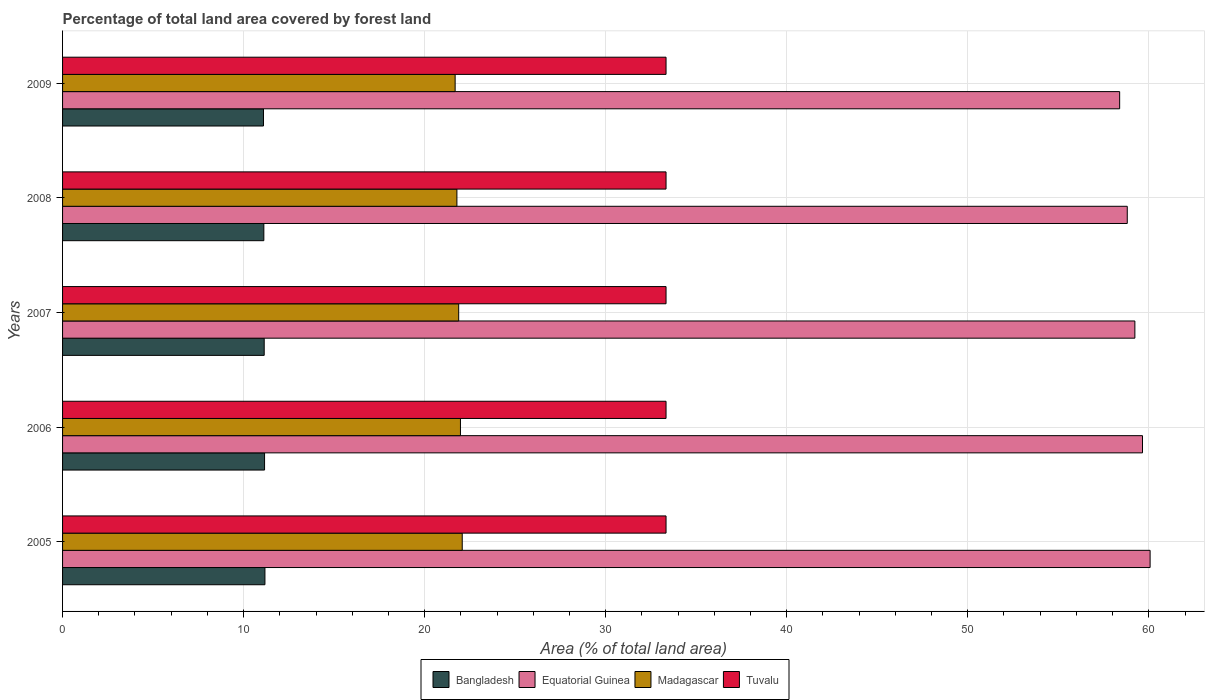Are the number of bars per tick equal to the number of legend labels?
Your answer should be very brief. Yes. Are the number of bars on each tick of the Y-axis equal?
Your response must be concise. Yes. How many bars are there on the 3rd tick from the top?
Offer a very short reply. 4. In how many cases, is the number of bars for a given year not equal to the number of legend labels?
Provide a succinct answer. 0. What is the percentage of forest land in Equatorial Guinea in 2009?
Your answer should be compact. 58.39. Across all years, what is the maximum percentage of forest land in Madagascar?
Ensure brevity in your answer.  22.08. Across all years, what is the minimum percentage of forest land in Bangladesh?
Provide a short and direct response. 11.1. In which year was the percentage of forest land in Tuvalu minimum?
Offer a terse response. 2005. What is the total percentage of forest land in Bangladesh in the graph?
Ensure brevity in your answer.  55.69. What is the difference between the percentage of forest land in Madagascar in 2006 and that in 2007?
Keep it short and to the point. 0.1. What is the difference between the percentage of forest land in Madagascar in 2008 and the percentage of forest land in Equatorial Guinea in 2007?
Make the answer very short. -37.45. What is the average percentage of forest land in Bangladesh per year?
Provide a succinct answer. 11.14. In the year 2009, what is the difference between the percentage of forest land in Equatorial Guinea and percentage of forest land in Madagascar?
Your answer should be compact. 36.7. In how many years, is the percentage of forest land in Madagascar greater than 4 %?
Keep it short and to the point. 5. What is the ratio of the percentage of forest land in Equatorial Guinea in 2005 to that in 2008?
Your response must be concise. 1.02. What is the difference between the highest and the second highest percentage of forest land in Bangladesh?
Keep it short and to the point. 0.02. What is the difference between the highest and the lowest percentage of forest land in Madagascar?
Provide a succinct answer. 0.39. Is it the case that in every year, the sum of the percentage of forest land in Bangladesh and percentage of forest land in Tuvalu is greater than the sum of percentage of forest land in Madagascar and percentage of forest land in Equatorial Guinea?
Provide a succinct answer. Yes. What does the 1st bar from the top in 2009 represents?
Your answer should be compact. Tuvalu. What does the 4th bar from the bottom in 2009 represents?
Offer a terse response. Tuvalu. How many bars are there?
Your answer should be compact. 20. How many years are there in the graph?
Your response must be concise. 5. Does the graph contain any zero values?
Offer a very short reply. No. What is the title of the graph?
Your answer should be very brief. Percentage of total land area covered by forest land. What is the label or title of the X-axis?
Offer a very short reply. Area (% of total land area). What is the label or title of the Y-axis?
Offer a very short reply. Years. What is the Area (% of total land area) of Bangladesh in 2005?
Ensure brevity in your answer.  11.18. What is the Area (% of total land area) of Equatorial Guinea in 2005?
Your answer should be compact. 60.07. What is the Area (% of total land area) of Madagascar in 2005?
Provide a short and direct response. 22.08. What is the Area (% of total land area) in Tuvalu in 2005?
Offer a terse response. 33.33. What is the Area (% of total land area) of Bangladesh in 2006?
Offer a terse response. 11.16. What is the Area (% of total land area) in Equatorial Guinea in 2006?
Give a very brief answer. 59.65. What is the Area (% of total land area) in Madagascar in 2006?
Provide a succinct answer. 21.98. What is the Area (% of total land area) in Tuvalu in 2006?
Give a very brief answer. 33.33. What is the Area (% of total land area) of Bangladesh in 2007?
Give a very brief answer. 11.14. What is the Area (% of total land area) of Equatorial Guinea in 2007?
Your answer should be compact. 59.23. What is the Area (% of total land area) in Madagascar in 2007?
Your response must be concise. 21.88. What is the Area (% of total land area) in Tuvalu in 2007?
Keep it short and to the point. 33.33. What is the Area (% of total land area) of Bangladesh in 2008?
Make the answer very short. 11.12. What is the Area (% of total land area) of Equatorial Guinea in 2008?
Provide a short and direct response. 58.81. What is the Area (% of total land area) in Madagascar in 2008?
Give a very brief answer. 21.78. What is the Area (% of total land area) of Tuvalu in 2008?
Keep it short and to the point. 33.33. What is the Area (% of total land area) of Bangladesh in 2009?
Provide a succinct answer. 11.1. What is the Area (% of total land area) in Equatorial Guinea in 2009?
Ensure brevity in your answer.  58.39. What is the Area (% of total land area) of Madagascar in 2009?
Ensure brevity in your answer.  21.68. What is the Area (% of total land area) in Tuvalu in 2009?
Provide a succinct answer. 33.33. Across all years, what is the maximum Area (% of total land area) in Bangladesh?
Your answer should be compact. 11.18. Across all years, what is the maximum Area (% of total land area) of Equatorial Guinea?
Offer a terse response. 60.07. Across all years, what is the maximum Area (% of total land area) of Madagascar?
Make the answer very short. 22.08. Across all years, what is the maximum Area (% of total land area) of Tuvalu?
Your response must be concise. 33.33. Across all years, what is the minimum Area (% of total land area) of Bangladesh?
Provide a short and direct response. 11.1. Across all years, what is the minimum Area (% of total land area) of Equatorial Guinea?
Ensure brevity in your answer.  58.39. Across all years, what is the minimum Area (% of total land area) in Madagascar?
Ensure brevity in your answer.  21.68. Across all years, what is the minimum Area (% of total land area) in Tuvalu?
Offer a very short reply. 33.33. What is the total Area (% of total land area) of Bangladesh in the graph?
Offer a terse response. 55.69. What is the total Area (% of total land area) of Equatorial Guinea in the graph?
Offer a very short reply. 296.15. What is the total Area (% of total land area) of Madagascar in the graph?
Provide a succinct answer. 109.4. What is the total Area (% of total land area) in Tuvalu in the graph?
Offer a very short reply. 166.67. What is the difference between the Area (% of total land area) in Equatorial Guinea in 2005 and that in 2006?
Make the answer very short. 0.42. What is the difference between the Area (% of total land area) in Madagascar in 2005 and that in 2006?
Your answer should be compact. 0.1. What is the difference between the Area (% of total land area) in Bangladesh in 2005 and that in 2007?
Offer a very short reply. 0.04. What is the difference between the Area (% of total land area) of Equatorial Guinea in 2005 and that in 2007?
Ensure brevity in your answer.  0.84. What is the difference between the Area (% of total land area) of Madagascar in 2005 and that in 2007?
Provide a succinct answer. 0.2. What is the difference between the Area (% of total land area) in Bangladesh in 2005 and that in 2008?
Give a very brief answer. 0.06. What is the difference between the Area (% of total land area) in Equatorial Guinea in 2005 and that in 2008?
Your response must be concise. 1.26. What is the difference between the Area (% of total land area) of Madagascar in 2005 and that in 2008?
Make the answer very short. 0.29. What is the difference between the Area (% of total land area) in Bangladesh in 2005 and that in 2009?
Make the answer very short. 0.08. What is the difference between the Area (% of total land area) of Equatorial Guinea in 2005 and that in 2009?
Give a very brief answer. 1.68. What is the difference between the Area (% of total land area) in Madagascar in 2005 and that in 2009?
Provide a succinct answer. 0.39. What is the difference between the Area (% of total land area) of Tuvalu in 2005 and that in 2009?
Give a very brief answer. 0. What is the difference between the Area (% of total land area) of Equatorial Guinea in 2006 and that in 2007?
Give a very brief answer. 0.42. What is the difference between the Area (% of total land area) of Madagascar in 2006 and that in 2007?
Make the answer very short. 0.1. What is the difference between the Area (% of total land area) of Bangladesh in 2006 and that in 2008?
Your answer should be compact. 0.04. What is the difference between the Area (% of total land area) in Equatorial Guinea in 2006 and that in 2008?
Provide a succinct answer. 0.84. What is the difference between the Area (% of total land area) in Madagascar in 2006 and that in 2008?
Give a very brief answer. 0.2. What is the difference between the Area (% of total land area) of Tuvalu in 2006 and that in 2008?
Provide a succinct answer. 0. What is the difference between the Area (% of total land area) in Bangladesh in 2006 and that in 2009?
Offer a very short reply. 0.06. What is the difference between the Area (% of total land area) in Equatorial Guinea in 2006 and that in 2009?
Offer a terse response. 1.26. What is the difference between the Area (% of total land area) of Madagascar in 2006 and that in 2009?
Offer a very short reply. 0.29. What is the difference between the Area (% of total land area) of Tuvalu in 2006 and that in 2009?
Offer a terse response. 0. What is the difference between the Area (% of total land area) in Equatorial Guinea in 2007 and that in 2008?
Your answer should be compact. 0.42. What is the difference between the Area (% of total land area) in Madagascar in 2007 and that in 2008?
Your answer should be compact. 0.1. What is the difference between the Area (% of total land area) in Tuvalu in 2007 and that in 2008?
Your answer should be very brief. 0. What is the difference between the Area (% of total land area) in Bangladesh in 2007 and that in 2009?
Your response must be concise. 0.04. What is the difference between the Area (% of total land area) of Equatorial Guinea in 2007 and that in 2009?
Your answer should be very brief. 0.84. What is the difference between the Area (% of total land area) in Madagascar in 2007 and that in 2009?
Your answer should be very brief. 0.2. What is the difference between the Area (% of total land area) in Equatorial Guinea in 2008 and that in 2009?
Provide a short and direct response. 0.42. What is the difference between the Area (% of total land area) in Madagascar in 2008 and that in 2009?
Give a very brief answer. 0.1. What is the difference between the Area (% of total land area) in Bangladesh in 2005 and the Area (% of total land area) in Equatorial Guinea in 2006?
Offer a very short reply. -48.47. What is the difference between the Area (% of total land area) of Bangladesh in 2005 and the Area (% of total land area) of Madagascar in 2006?
Ensure brevity in your answer.  -10.8. What is the difference between the Area (% of total land area) of Bangladesh in 2005 and the Area (% of total land area) of Tuvalu in 2006?
Make the answer very short. -22.16. What is the difference between the Area (% of total land area) in Equatorial Guinea in 2005 and the Area (% of total land area) in Madagascar in 2006?
Offer a very short reply. 38.09. What is the difference between the Area (% of total land area) in Equatorial Guinea in 2005 and the Area (% of total land area) in Tuvalu in 2006?
Your response must be concise. 26.74. What is the difference between the Area (% of total land area) of Madagascar in 2005 and the Area (% of total land area) of Tuvalu in 2006?
Ensure brevity in your answer.  -11.26. What is the difference between the Area (% of total land area) in Bangladesh in 2005 and the Area (% of total land area) in Equatorial Guinea in 2007?
Offer a terse response. -48.05. What is the difference between the Area (% of total land area) of Bangladesh in 2005 and the Area (% of total land area) of Madagascar in 2007?
Your answer should be compact. -10.7. What is the difference between the Area (% of total land area) in Bangladesh in 2005 and the Area (% of total land area) in Tuvalu in 2007?
Your response must be concise. -22.16. What is the difference between the Area (% of total land area) of Equatorial Guinea in 2005 and the Area (% of total land area) of Madagascar in 2007?
Offer a terse response. 38.19. What is the difference between the Area (% of total land area) of Equatorial Guinea in 2005 and the Area (% of total land area) of Tuvalu in 2007?
Your answer should be very brief. 26.74. What is the difference between the Area (% of total land area) of Madagascar in 2005 and the Area (% of total land area) of Tuvalu in 2007?
Give a very brief answer. -11.26. What is the difference between the Area (% of total land area) of Bangladesh in 2005 and the Area (% of total land area) of Equatorial Guinea in 2008?
Your response must be concise. -47.63. What is the difference between the Area (% of total land area) in Bangladesh in 2005 and the Area (% of total land area) in Madagascar in 2008?
Provide a short and direct response. -10.6. What is the difference between the Area (% of total land area) of Bangladesh in 2005 and the Area (% of total land area) of Tuvalu in 2008?
Your answer should be very brief. -22.16. What is the difference between the Area (% of total land area) in Equatorial Guinea in 2005 and the Area (% of total land area) in Madagascar in 2008?
Offer a terse response. 38.29. What is the difference between the Area (% of total land area) in Equatorial Guinea in 2005 and the Area (% of total land area) in Tuvalu in 2008?
Offer a very short reply. 26.74. What is the difference between the Area (% of total land area) in Madagascar in 2005 and the Area (% of total land area) in Tuvalu in 2008?
Your response must be concise. -11.26. What is the difference between the Area (% of total land area) of Bangladesh in 2005 and the Area (% of total land area) of Equatorial Guinea in 2009?
Your response must be concise. -47.21. What is the difference between the Area (% of total land area) in Bangladesh in 2005 and the Area (% of total land area) in Madagascar in 2009?
Offer a terse response. -10.51. What is the difference between the Area (% of total land area) in Bangladesh in 2005 and the Area (% of total land area) in Tuvalu in 2009?
Your answer should be very brief. -22.16. What is the difference between the Area (% of total land area) in Equatorial Guinea in 2005 and the Area (% of total land area) in Madagascar in 2009?
Give a very brief answer. 38.39. What is the difference between the Area (% of total land area) in Equatorial Guinea in 2005 and the Area (% of total land area) in Tuvalu in 2009?
Provide a succinct answer. 26.74. What is the difference between the Area (% of total land area) of Madagascar in 2005 and the Area (% of total land area) of Tuvalu in 2009?
Ensure brevity in your answer.  -11.26. What is the difference between the Area (% of total land area) in Bangladesh in 2006 and the Area (% of total land area) in Equatorial Guinea in 2007?
Keep it short and to the point. -48.07. What is the difference between the Area (% of total land area) in Bangladesh in 2006 and the Area (% of total land area) in Madagascar in 2007?
Provide a short and direct response. -10.72. What is the difference between the Area (% of total land area) in Bangladesh in 2006 and the Area (% of total land area) in Tuvalu in 2007?
Your answer should be very brief. -22.18. What is the difference between the Area (% of total land area) of Equatorial Guinea in 2006 and the Area (% of total land area) of Madagascar in 2007?
Your answer should be very brief. 37.77. What is the difference between the Area (% of total land area) of Equatorial Guinea in 2006 and the Area (% of total land area) of Tuvalu in 2007?
Your response must be concise. 26.32. What is the difference between the Area (% of total land area) of Madagascar in 2006 and the Area (% of total land area) of Tuvalu in 2007?
Give a very brief answer. -11.36. What is the difference between the Area (% of total land area) in Bangladesh in 2006 and the Area (% of total land area) in Equatorial Guinea in 2008?
Ensure brevity in your answer.  -47.65. What is the difference between the Area (% of total land area) of Bangladesh in 2006 and the Area (% of total land area) of Madagascar in 2008?
Offer a very short reply. -10.62. What is the difference between the Area (% of total land area) in Bangladesh in 2006 and the Area (% of total land area) in Tuvalu in 2008?
Your response must be concise. -22.18. What is the difference between the Area (% of total land area) of Equatorial Guinea in 2006 and the Area (% of total land area) of Madagascar in 2008?
Provide a short and direct response. 37.87. What is the difference between the Area (% of total land area) in Equatorial Guinea in 2006 and the Area (% of total land area) in Tuvalu in 2008?
Offer a terse response. 26.32. What is the difference between the Area (% of total land area) of Madagascar in 2006 and the Area (% of total land area) of Tuvalu in 2008?
Ensure brevity in your answer.  -11.36. What is the difference between the Area (% of total land area) in Bangladesh in 2006 and the Area (% of total land area) in Equatorial Guinea in 2009?
Provide a short and direct response. -47.23. What is the difference between the Area (% of total land area) in Bangladesh in 2006 and the Area (% of total land area) in Madagascar in 2009?
Your response must be concise. -10.53. What is the difference between the Area (% of total land area) of Bangladesh in 2006 and the Area (% of total land area) of Tuvalu in 2009?
Give a very brief answer. -22.18. What is the difference between the Area (% of total land area) in Equatorial Guinea in 2006 and the Area (% of total land area) in Madagascar in 2009?
Ensure brevity in your answer.  37.97. What is the difference between the Area (% of total land area) in Equatorial Guinea in 2006 and the Area (% of total land area) in Tuvalu in 2009?
Give a very brief answer. 26.32. What is the difference between the Area (% of total land area) in Madagascar in 2006 and the Area (% of total land area) in Tuvalu in 2009?
Provide a short and direct response. -11.36. What is the difference between the Area (% of total land area) in Bangladesh in 2007 and the Area (% of total land area) in Equatorial Guinea in 2008?
Offer a very short reply. -47.67. What is the difference between the Area (% of total land area) of Bangladesh in 2007 and the Area (% of total land area) of Madagascar in 2008?
Your response must be concise. -10.64. What is the difference between the Area (% of total land area) in Bangladesh in 2007 and the Area (% of total land area) in Tuvalu in 2008?
Ensure brevity in your answer.  -22.2. What is the difference between the Area (% of total land area) of Equatorial Guinea in 2007 and the Area (% of total land area) of Madagascar in 2008?
Your answer should be compact. 37.45. What is the difference between the Area (% of total land area) in Equatorial Guinea in 2007 and the Area (% of total land area) in Tuvalu in 2008?
Provide a short and direct response. 25.9. What is the difference between the Area (% of total land area) in Madagascar in 2007 and the Area (% of total land area) in Tuvalu in 2008?
Provide a short and direct response. -11.45. What is the difference between the Area (% of total land area) of Bangladesh in 2007 and the Area (% of total land area) of Equatorial Guinea in 2009?
Your answer should be compact. -47.25. What is the difference between the Area (% of total land area) in Bangladesh in 2007 and the Area (% of total land area) in Madagascar in 2009?
Offer a terse response. -10.55. What is the difference between the Area (% of total land area) in Bangladesh in 2007 and the Area (% of total land area) in Tuvalu in 2009?
Make the answer very short. -22.2. What is the difference between the Area (% of total land area) of Equatorial Guinea in 2007 and the Area (% of total land area) of Madagascar in 2009?
Provide a short and direct response. 37.55. What is the difference between the Area (% of total land area) of Equatorial Guinea in 2007 and the Area (% of total land area) of Tuvalu in 2009?
Provide a succinct answer. 25.9. What is the difference between the Area (% of total land area) of Madagascar in 2007 and the Area (% of total land area) of Tuvalu in 2009?
Your response must be concise. -11.45. What is the difference between the Area (% of total land area) of Bangladesh in 2008 and the Area (% of total land area) of Equatorial Guinea in 2009?
Ensure brevity in your answer.  -47.27. What is the difference between the Area (% of total land area) in Bangladesh in 2008 and the Area (% of total land area) in Madagascar in 2009?
Your answer should be very brief. -10.57. What is the difference between the Area (% of total land area) of Bangladesh in 2008 and the Area (% of total land area) of Tuvalu in 2009?
Ensure brevity in your answer.  -22.22. What is the difference between the Area (% of total land area) of Equatorial Guinea in 2008 and the Area (% of total land area) of Madagascar in 2009?
Ensure brevity in your answer.  37.13. What is the difference between the Area (% of total land area) of Equatorial Guinea in 2008 and the Area (% of total land area) of Tuvalu in 2009?
Give a very brief answer. 25.48. What is the difference between the Area (% of total land area) in Madagascar in 2008 and the Area (% of total land area) in Tuvalu in 2009?
Provide a succinct answer. -11.55. What is the average Area (% of total land area) of Bangladesh per year?
Your answer should be very brief. 11.14. What is the average Area (% of total land area) of Equatorial Guinea per year?
Your answer should be compact. 59.23. What is the average Area (% of total land area) in Madagascar per year?
Keep it short and to the point. 21.88. What is the average Area (% of total land area) of Tuvalu per year?
Give a very brief answer. 33.33. In the year 2005, what is the difference between the Area (% of total land area) of Bangladesh and Area (% of total land area) of Equatorial Guinea?
Your response must be concise. -48.89. In the year 2005, what is the difference between the Area (% of total land area) of Bangladesh and Area (% of total land area) of Madagascar?
Provide a succinct answer. -10.9. In the year 2005, what is the difference between the Area (% of total land area) of Bangladesh and Area (% of total land area) of Tuvalu?
Your response must be concise. -22.16. In the year 2005, what is the difference between the Area (% of total land area) in Equatorial Guinea and Area (% of total land area) in Madagascar?
Your answer should be very brief. 38. In the year 2005, what is the difference between the Area (% of total land area) of Equatorial Guinea and Area (% of total land area) of Tuvalu?
Ensure brevity in your answer.  26.74. In the year 2005, what is the difference between the Area (% of total land area) in Madagascar and Area (% of total land area) in Tuvalu?
Offer a very short reply. -11.26. In the year 2006, what is the difference between the Area (% of total land area) in Bangladesh and Area (% of total land area) in Equatorial Guinea?
Your response must be concise. -48.49. In the year 2006, what is the difference between the Area (% of total land area) of Bangladesh and Area (% of total land area) of Madagascar?
Make the answer very short. -10.82. In the year 2006, what is the difference between the Area (% of total land area) in Bangladesh and Area (% of total land area) in Tuvalu?
Your answer should be very brief. -22.18. In the year 2006, what is the difference between the Area (% of total land area) in Equatorial Guinea and Area (% of total land area) in Madagascar?
Offer a terse response. 37.67. In the year 2006, what is the difference between the Area (% of total land area) of Equatorial Guinea and Area (% of total land area) of Tuvalu?
Make the answer very short. 26.32. In the year 2006, what is the difference between the Area (% of total land area) of Madagascar and Area (% of total land area) of Tuvalu?
Make the answer very short. -11.36. In the year 2007, what is the difference between the Area (% of total land area) of Bangladesh and Area (% of total land area) of Equatorial Guinea?
Keep it short and to the point. -48.09. In the year 2007, what is the difference between the Area (% of total land area) in Bangladesh and Area (% of total land area) in Madagascar?
Provide a succinct answer. -10.74. In the year 2007, what is the difference between the Area (% of total land area) in Bangladesh and Area (% of total land area) in Tuvalu?
Your answer should be compact. -22.2. In the year 2007, what is the difference between the Area (% of total land area) of Equatorial Guinea and Area (% of total land area) of Madagascar?
Offer a very short reply. 37.35. In the year 2007, what is the difference between the Area (% of total land area) in Equatorial Guinea and Area (% of total land area) in Tuvalu?
Make the answer very short. 25.9. In the year 2007, what is the difference between the Area (% of total land area) in Madagascar and Area (% of total land area) in Tuvalu?
Give a very brief answer. -11.45. In the year 2008, what is the difference between the Area (% of total land area) in Bangladesh and Area (% of total land area) in Equatorial Guinea?
Give a very brief answer. -47.69. In the year 2008, what is the difference between the Area (% of total land area) of Bangladesh and Area (% of total land area) of Madagascar?
Keep it short and to the point. -10.66. In the year 2008, what is the difference between the Area (% of total land area) of Bangladesh and Area (% of total land area) of Tuvalu?
Your answer should be very brief. -22.22. In the year 2008, what is the difference between the Area (% of total land area) of Equatorial Guinea and Area (% of total land area) of Madagascar?
Offer a terse response. 37.03. In the year 2008, what is the difference between the Area (% of total land area) in Equatorial Guinea and Area (% of total land area) in Tuvalu?
Make the answer very short. 25.48. In the year 2008, what is the difference between the Area (% of total land area) of Madagascar and Area (% of total land area) of Tuvalu?
Your response must be concise. -11.55. In the year 2009, what is the difference between the Area (% of total land area) in Bangladesh and Area (% of total land area) in Equatorial Guinea?
Your answer should be very brief. -47.29. In the year 2009, what is the difference between the Area (% of total land area) of Bangladesh and Area (% of total land area) of Madagascar?
Provide a short and direct response. -10.59. In the year 2009, what is the difference between the Area (% of total land area) of Bangladesh and Area (% of total land area) of Tuvalu?
Ensure brevity in your answer.  -22.24. In the year 2009, what is the difference between the Area (% of total land area) in Equatorial Guinea and Area (% of total land area) in Madagascar?
Offer a terse response. 36.7. In the year 2009, what is the difference between the Area (% of total land area) of Equatorial Guinea and Area (% of total land area) of Tuvalu?
Make the answer very short. 25.06. In the year 2009, what is the difference between the Area (% of total land area) in Madagascar and Area (% of total land area) in Tuvalu?
Your response must be concise. -11.65. What is the ratio of the Area (% of total land area) of Bangladesh in 2005 to that in 2006?
Make the answer very short. 1. What is the ratio of the Area (% of total land area) of Equatorial Guinea in 2005 to that in 2006?
Your response must be concise. 1.01. What is the ratio of the Area (% of total land area) of Bangladesh in 2005 to that in 2007?
Provide a succinct answer. 1. What is the ratio of the Area (% of total land area) of Equatorial Guinea in 2005 to that in 2007?
Make the answer very short. 1.01. What is the ratio of the Area (% of total land area) of Bangladesh in 2005 to that in 2008?
Your response must be concise. 1.01. What is the ratio of the Area (% of total land area) in Equatorial Guinea in 2005 to that in 2008?
Keep it short and to the point. 1.02. What is the ratio of the Area (% of total land area) of Madagascar in 2005 to that in 2008?
Give a very brief answer. 1.01. What is the ratio of the Area (% of total land area) of Tuvalu in 2005 to that in 2008?
Your answer should be compact. 1. What is the ratio of the Area (% of total land area) of Equatorial Guinea in 2005 to that in 2009?
Your answer should be very brief. 1.03. What is the ratio of the Area (% of total land area) in Madagascar in 2005 to that in 2009?
Keep it short and to the point. 1.02. What is the ratio of the Area (% of total land area) of Bangladesh in 2006 to that in 2007?
Your answer should be compact. 1. What is the ratio of the Area (% of total land area) in Equatorial Guinea in 2006 to that in 2007?
Provide a succinct answer. 1.01. What is the ratio of the Area (% of total land area) in Madagascar in 2006 to that in 2007?
Ensure brevity in your answer.  1. What is the ratio of the Area (% of total land area) of Equatorial Guinea in 2006 to that in 2008?
Make the answer very short. 1.01. What is the ratio of the Area (% of total land area) in Madagascar in 2006 to that in 2008?
Make the answer very short. 1.01. What is the ratio of the Area (% of total land area) of Bangladesh in 2006 to that in 2009?
Your response must be concise. 1.01. What is the ratio of the Area (% of total land area) in Equatorial Guinea in 2006 to that in 2009?
Keep it short and to the point. 1.02. What is the ratio of the Area (% of total land area) in Madagascar in 2006 to that in 2009?
Provide a succinct answer. 1.01. What is the ratio of the Area (% of total land area) in Tuvalu in 2006 to that in 2009?
Ensure brevity in your answer.  1. What is the ratio of the Area (% of total land area) of Bangladesh in 2007 to that in 2008?
Offer a very short reply. 1. What is the ratio of the Area (% of total land area) of Madagascar in 2007 to that in 2008?
Your answer should be compact. 1. What is the ratio of the Area (% of total land area) in Equatorial Guinea in 2007 to that in 2009?
Keep it short and to the point. 1.01. What is the ratio of the Area (% of total land area) in Madagascar in 2007 to that in 2009?
Offer a terse response. 1.01. What is the ratio of the Area (% of total land area) in Tuvalu in 2007 to that in 2009?
Give a very brief answer. 1. What is the difference between the highest and the second highest Area (% of total land area) of Equatorial Guinea?
Offer a terse response. 0.42. What is the difference between the highest and the second highest Area (% of total land area) in Madagascar?
Offer a very short reply. 0.1. What is the difference between the highest and the lowest Area (% of total land area) in Bangladesh?
Provide a succinct answer. 0.08. What is the difference between the highest and the lowest Area (% of total land area) of Equatorial Guinea?
Offer a terse response. 1.68. What is the difference between the highest and the lowest Area (% of total land area) of Madagascar?
Offer a terse response. 0.39. 